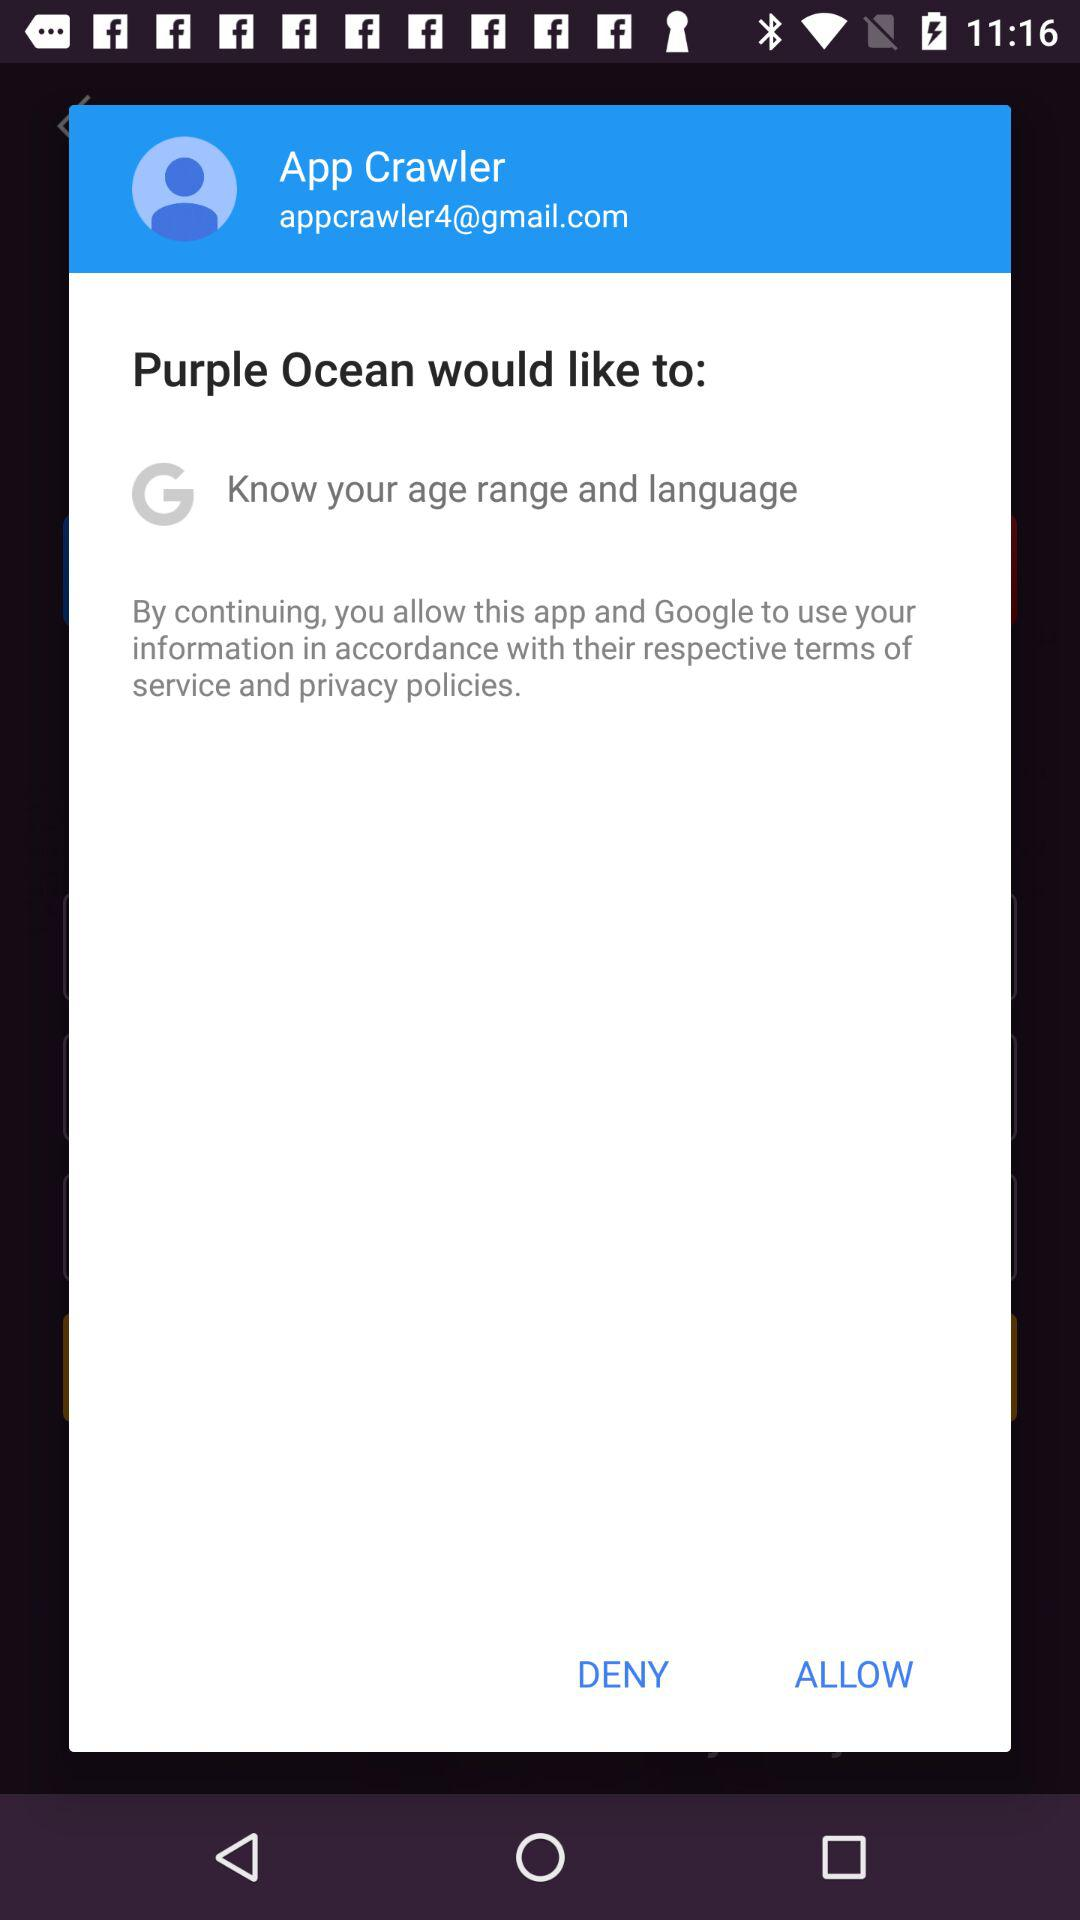What is the user name? The user name is App Crawler. 